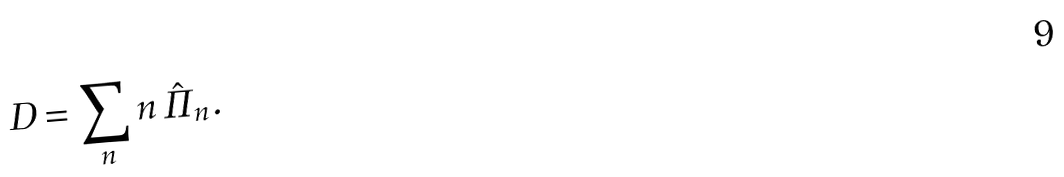Convert formula to latex. <formula><loc_0><loc_0><loc_500><loc_500>D = \sum _ { n } n \, \hat { \Pi } _ { n } .</formula> 